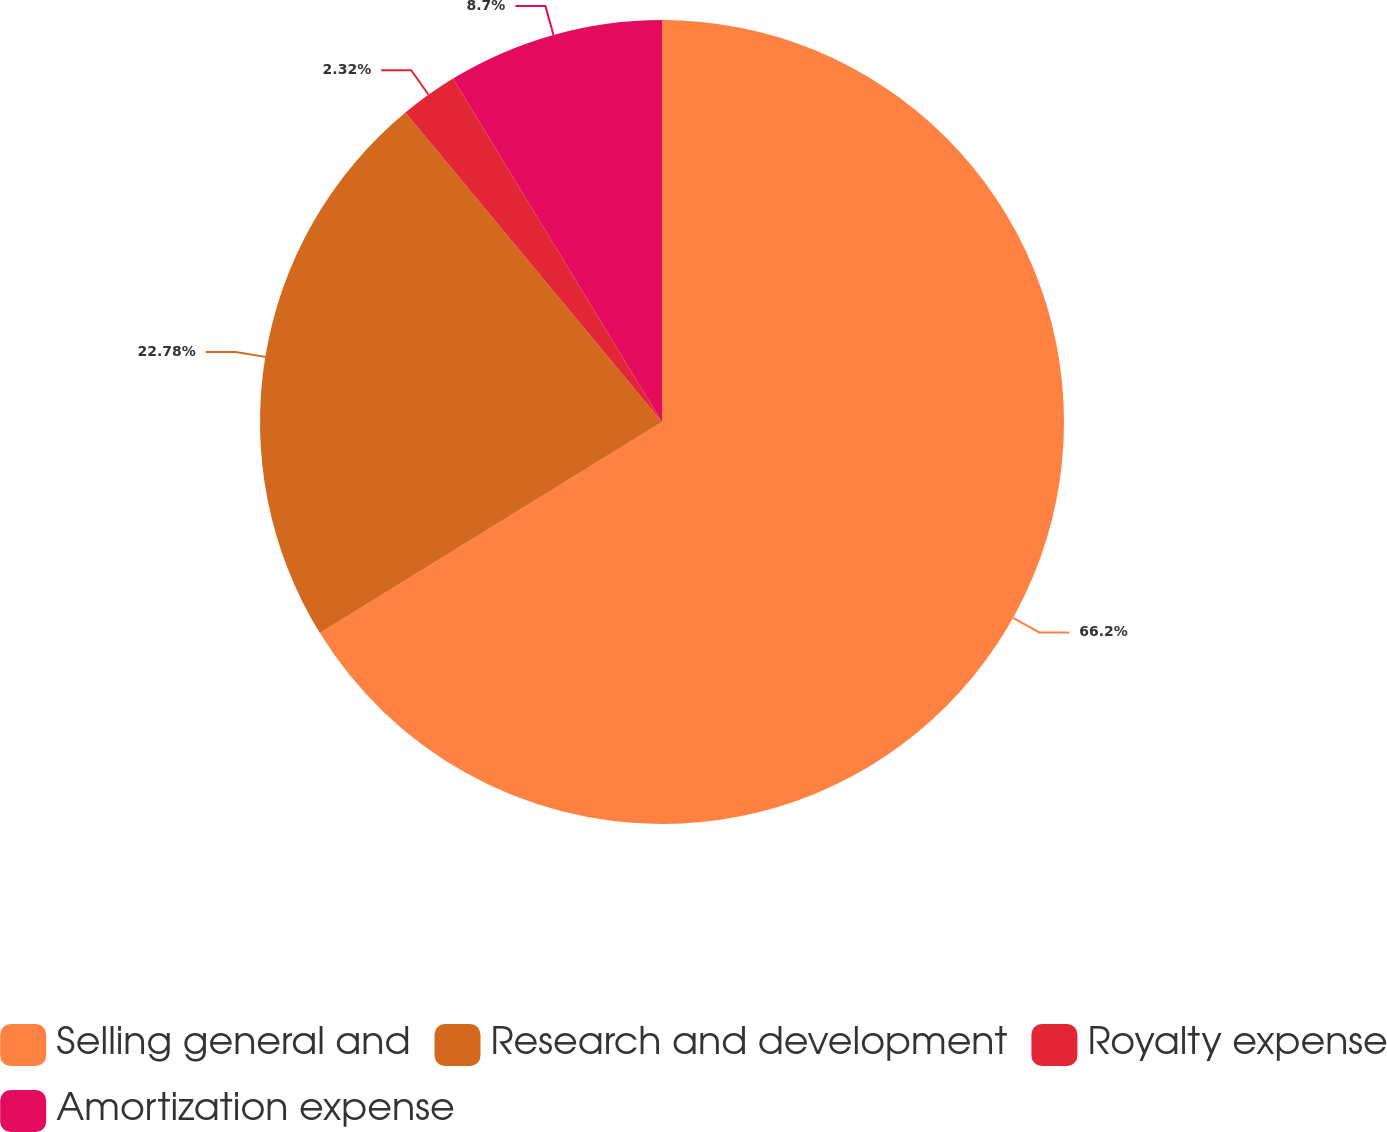<chart> <loc_0><loc_0><loc_500><loc_500><pie_chart><fcel>Selling general and<fcel>Research and development<fcel>Royalty expense<fcel>Amortization expense<nl><fcel>66.2%<fcel>22.78%<fcel>2.32%<fcel>8.7%<nl></chart> 